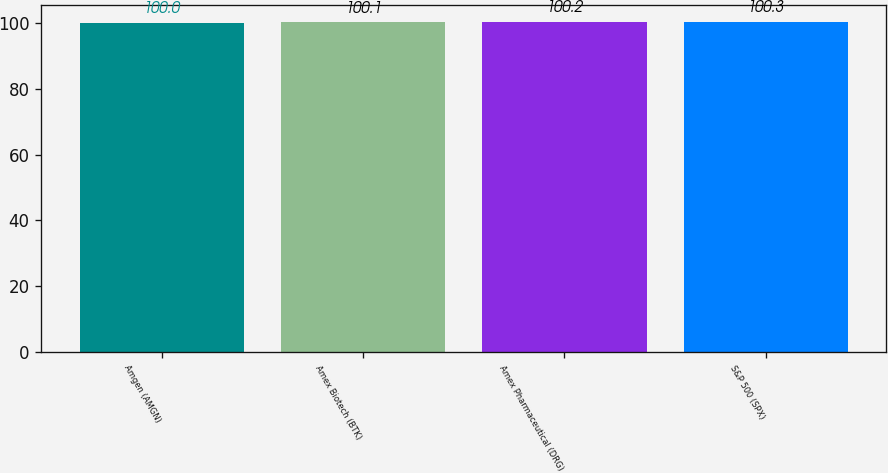Convert chart. <chart><loc_0><loc_0><loc_500><loc_500><bar_chart><fcel>Amgen (AMGN)<fcel>Amex Biotech (BTK)<fcel>Amex Pharmaceutical (DRG)<fcel>S&P 500 (SPX)<nl><fcel>100<fcel>100.1<fcel>100.2<fcel>100.3<nl></chart> 